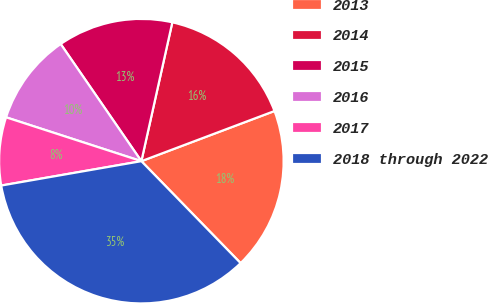Convert chart to OTSL. <chart><loc_0><loc_0><loc_500><loc_500><pie_chart><fcel>2013<fcel>2014<fcel>2015<fcel>2016<fcel>2017<fcel>2018 through 2022<nl><fcel>18.45%<fcel>15.77%<fcel>13.09%<fcel>10.41%<fcel>7.73%<fcel>34.54%<nl></chart> 